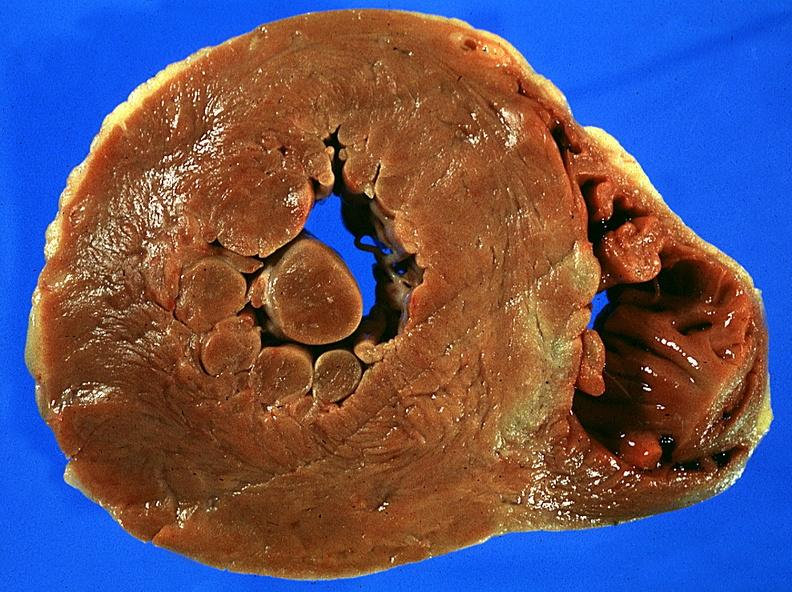s mesothelioma present?
Answer the question using a single word or phrase. No 